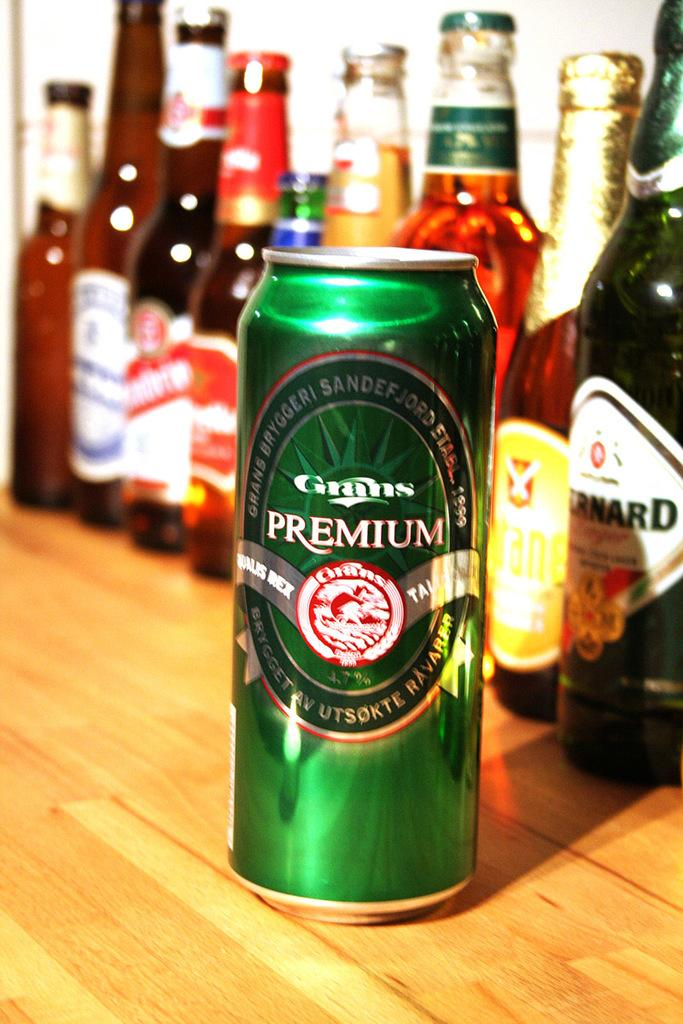<image>
Describe the image concisely. The name Grans Premium is visible on the side of a can of beer. 